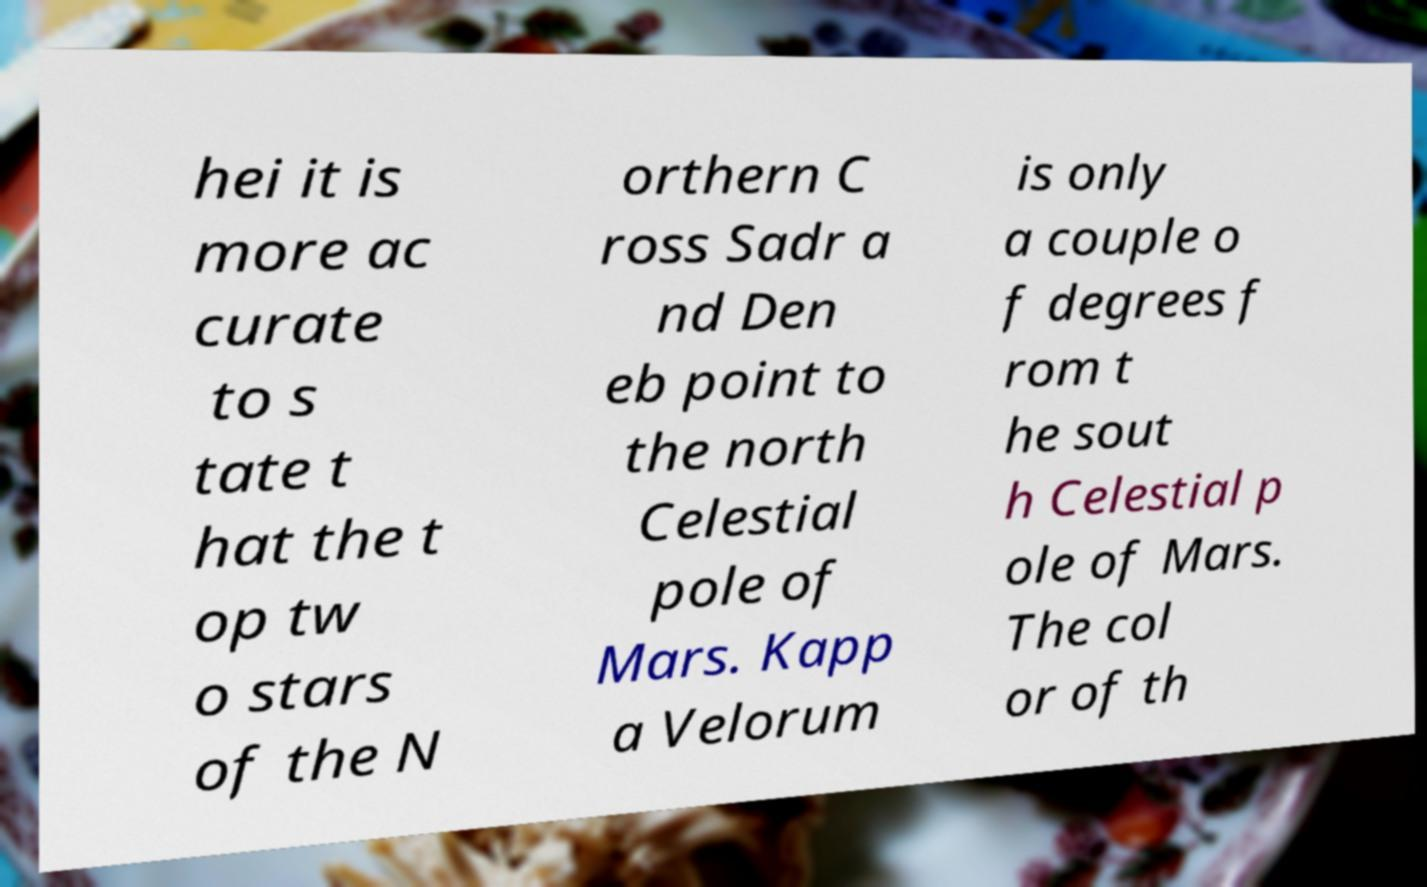Could you assist in decoding the text presented in this image and type it out clearly? hei it is more ac curate to s tate t hat the t op tw o stars of the N orthern C ross Sadr a nd Den eb point to the north Celestial pole of Mars. Kapp a Velorum is only a couple o f degrees f rom t he sout h Celestial p ole of Mars. The col or of th 